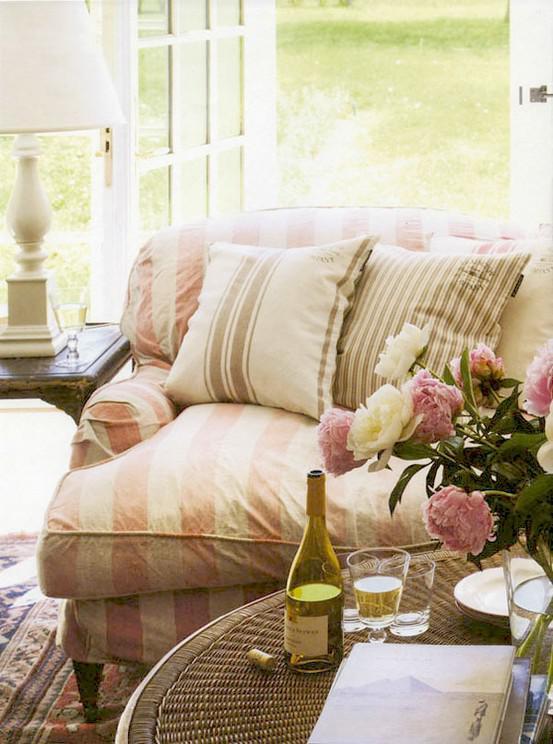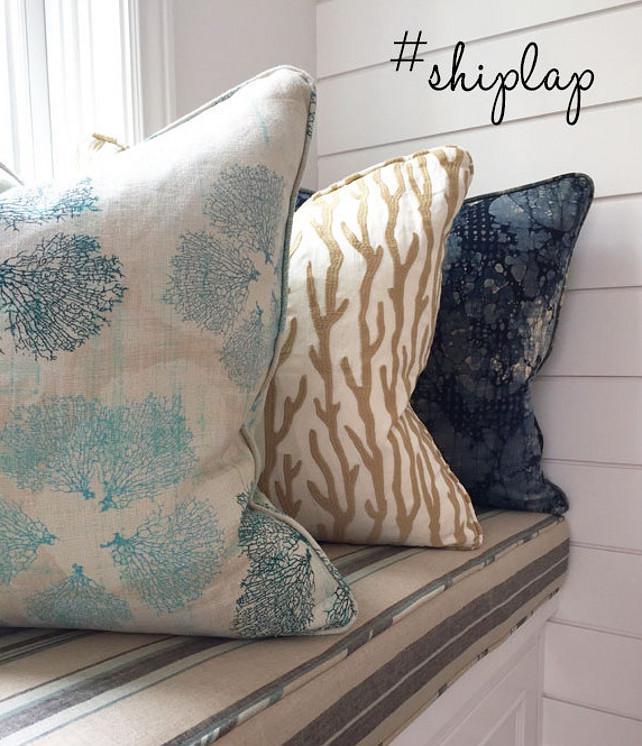The first image is the image on the left, the second image is the image on the right. Evaluate the accuracy of this statement regarding the images: "There are four different pillow sitting on a cream colored sofa.". Is it true? Answer yes or no. No. The first image is the image on the left, the second image is the image on the right. Considering the images on both sides, is "There are ten pillows total." valid? Answer yes or no. No. 